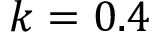Convert formula to latex. <formula><loc_0><loc_0><loc_500><loc_500>k = 0 . 4</formula> 